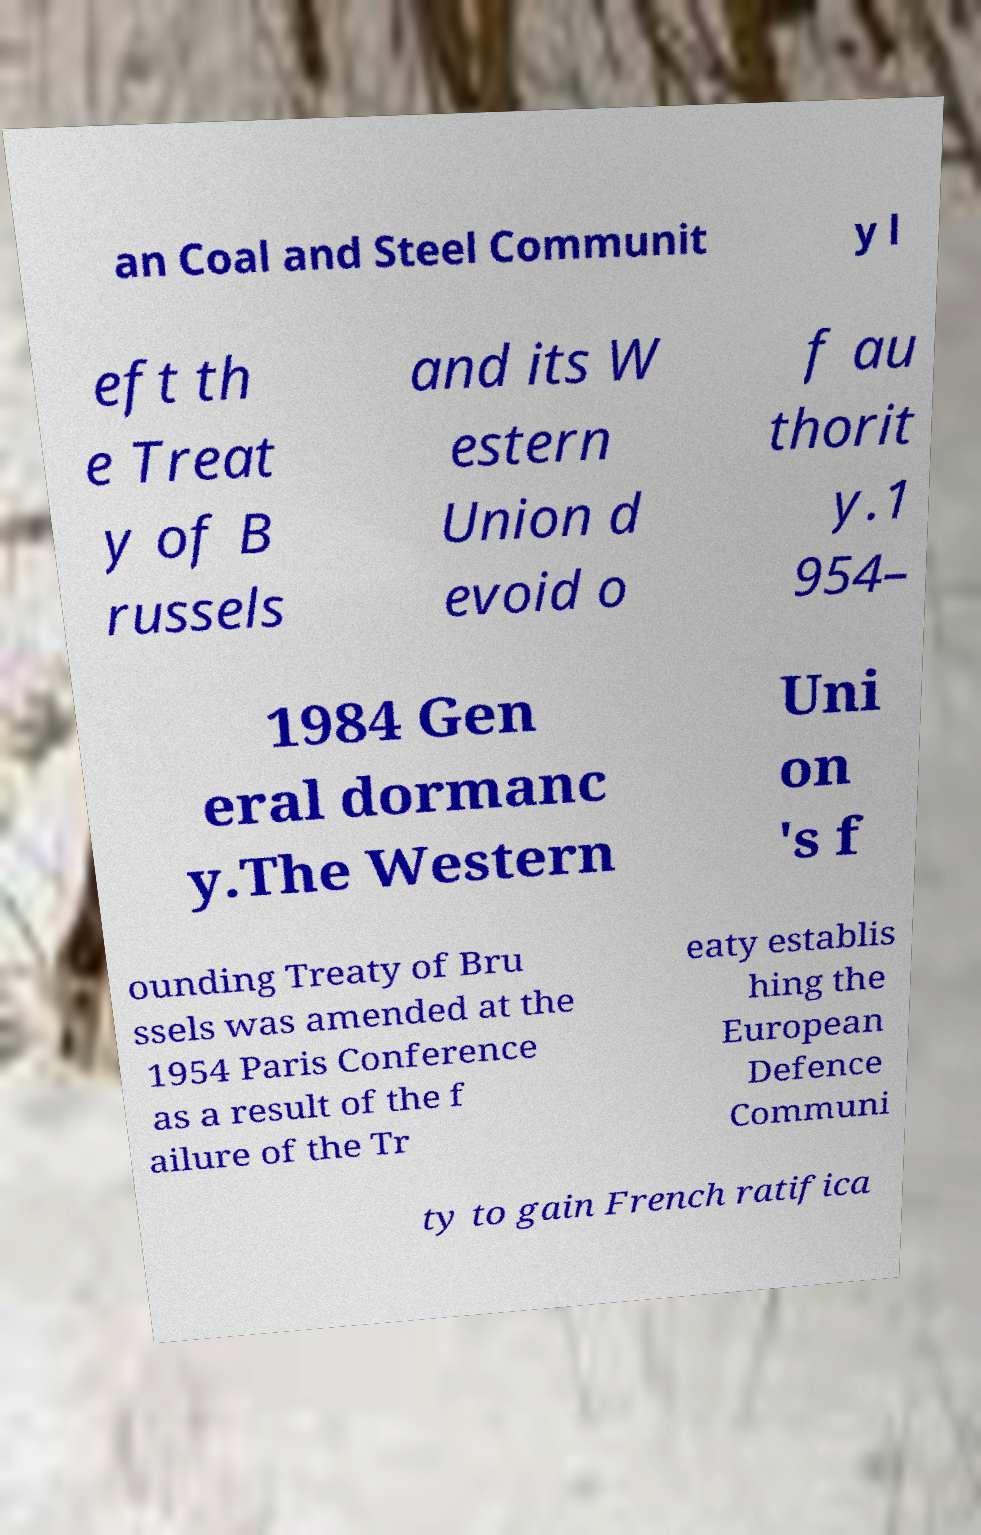Can you read and provide the text displayed in the image?This photo seems to have some interesting text. Can you extract and type it out for me? an Coal and Steel Communit y l eft th e Treat y of B russels and its W estern Union d evoid o f au thorit y.1 954– 1984 Gen eral dormanc y.The Western Uni on 's f ounding Treaty of Bru ssels was amended at the 1954 Paris Conference as a result of the f ailure of the Tr eaty establis hing the European Defence Communi ty to gain French ratifica 